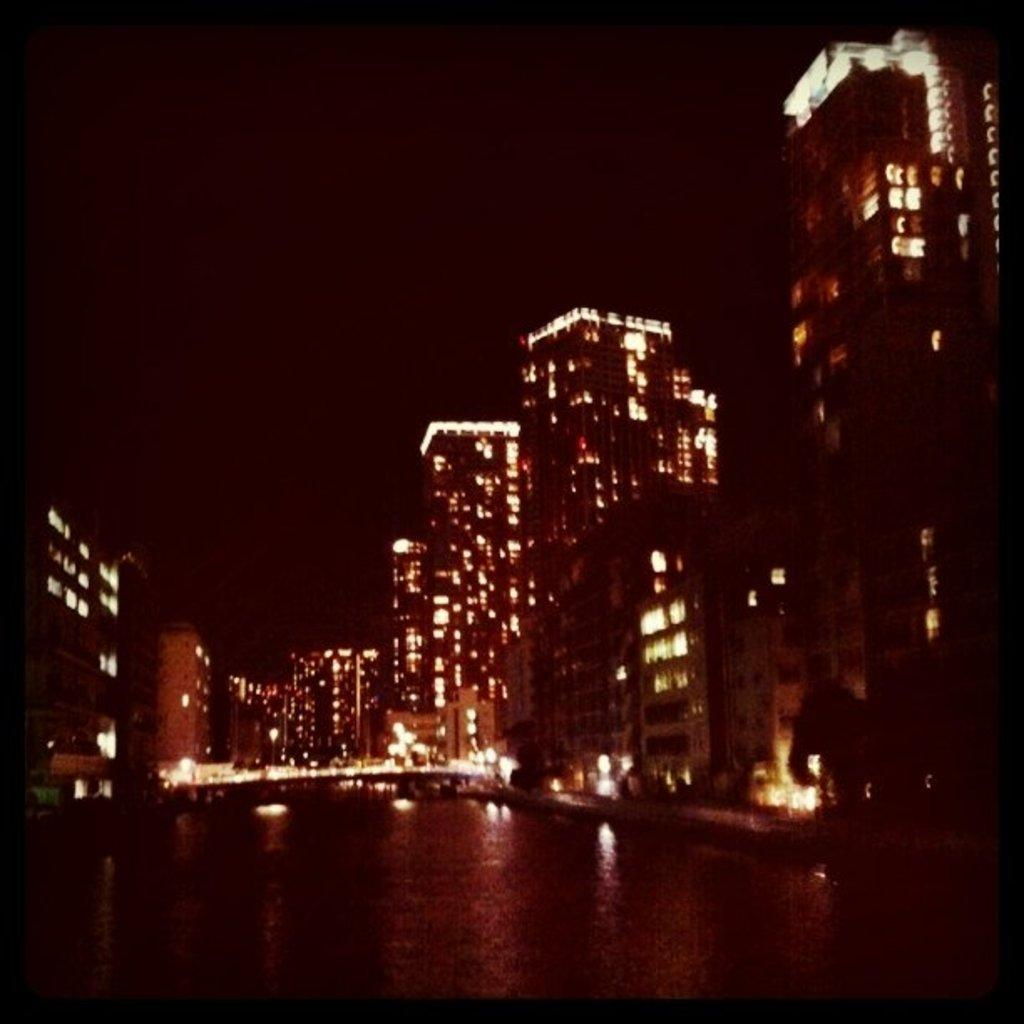What structures are present in the image? There are buildings in the image. What feature can be observed about the buildings? The buildings have lighting. What natural element is visible in the image? There is a water surface visible in the image. What type of line or rod can be seen hanging from the buildings in the image? There is no line or rod hanging from the buildings in the image. Can you tell me how many pears are present on the water surface in the image? There are no pears present on the water surface in the image. 